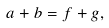<formula> <loc_0><loc_0><loc_500><loc_500>a + b = f + g ,</formula> 